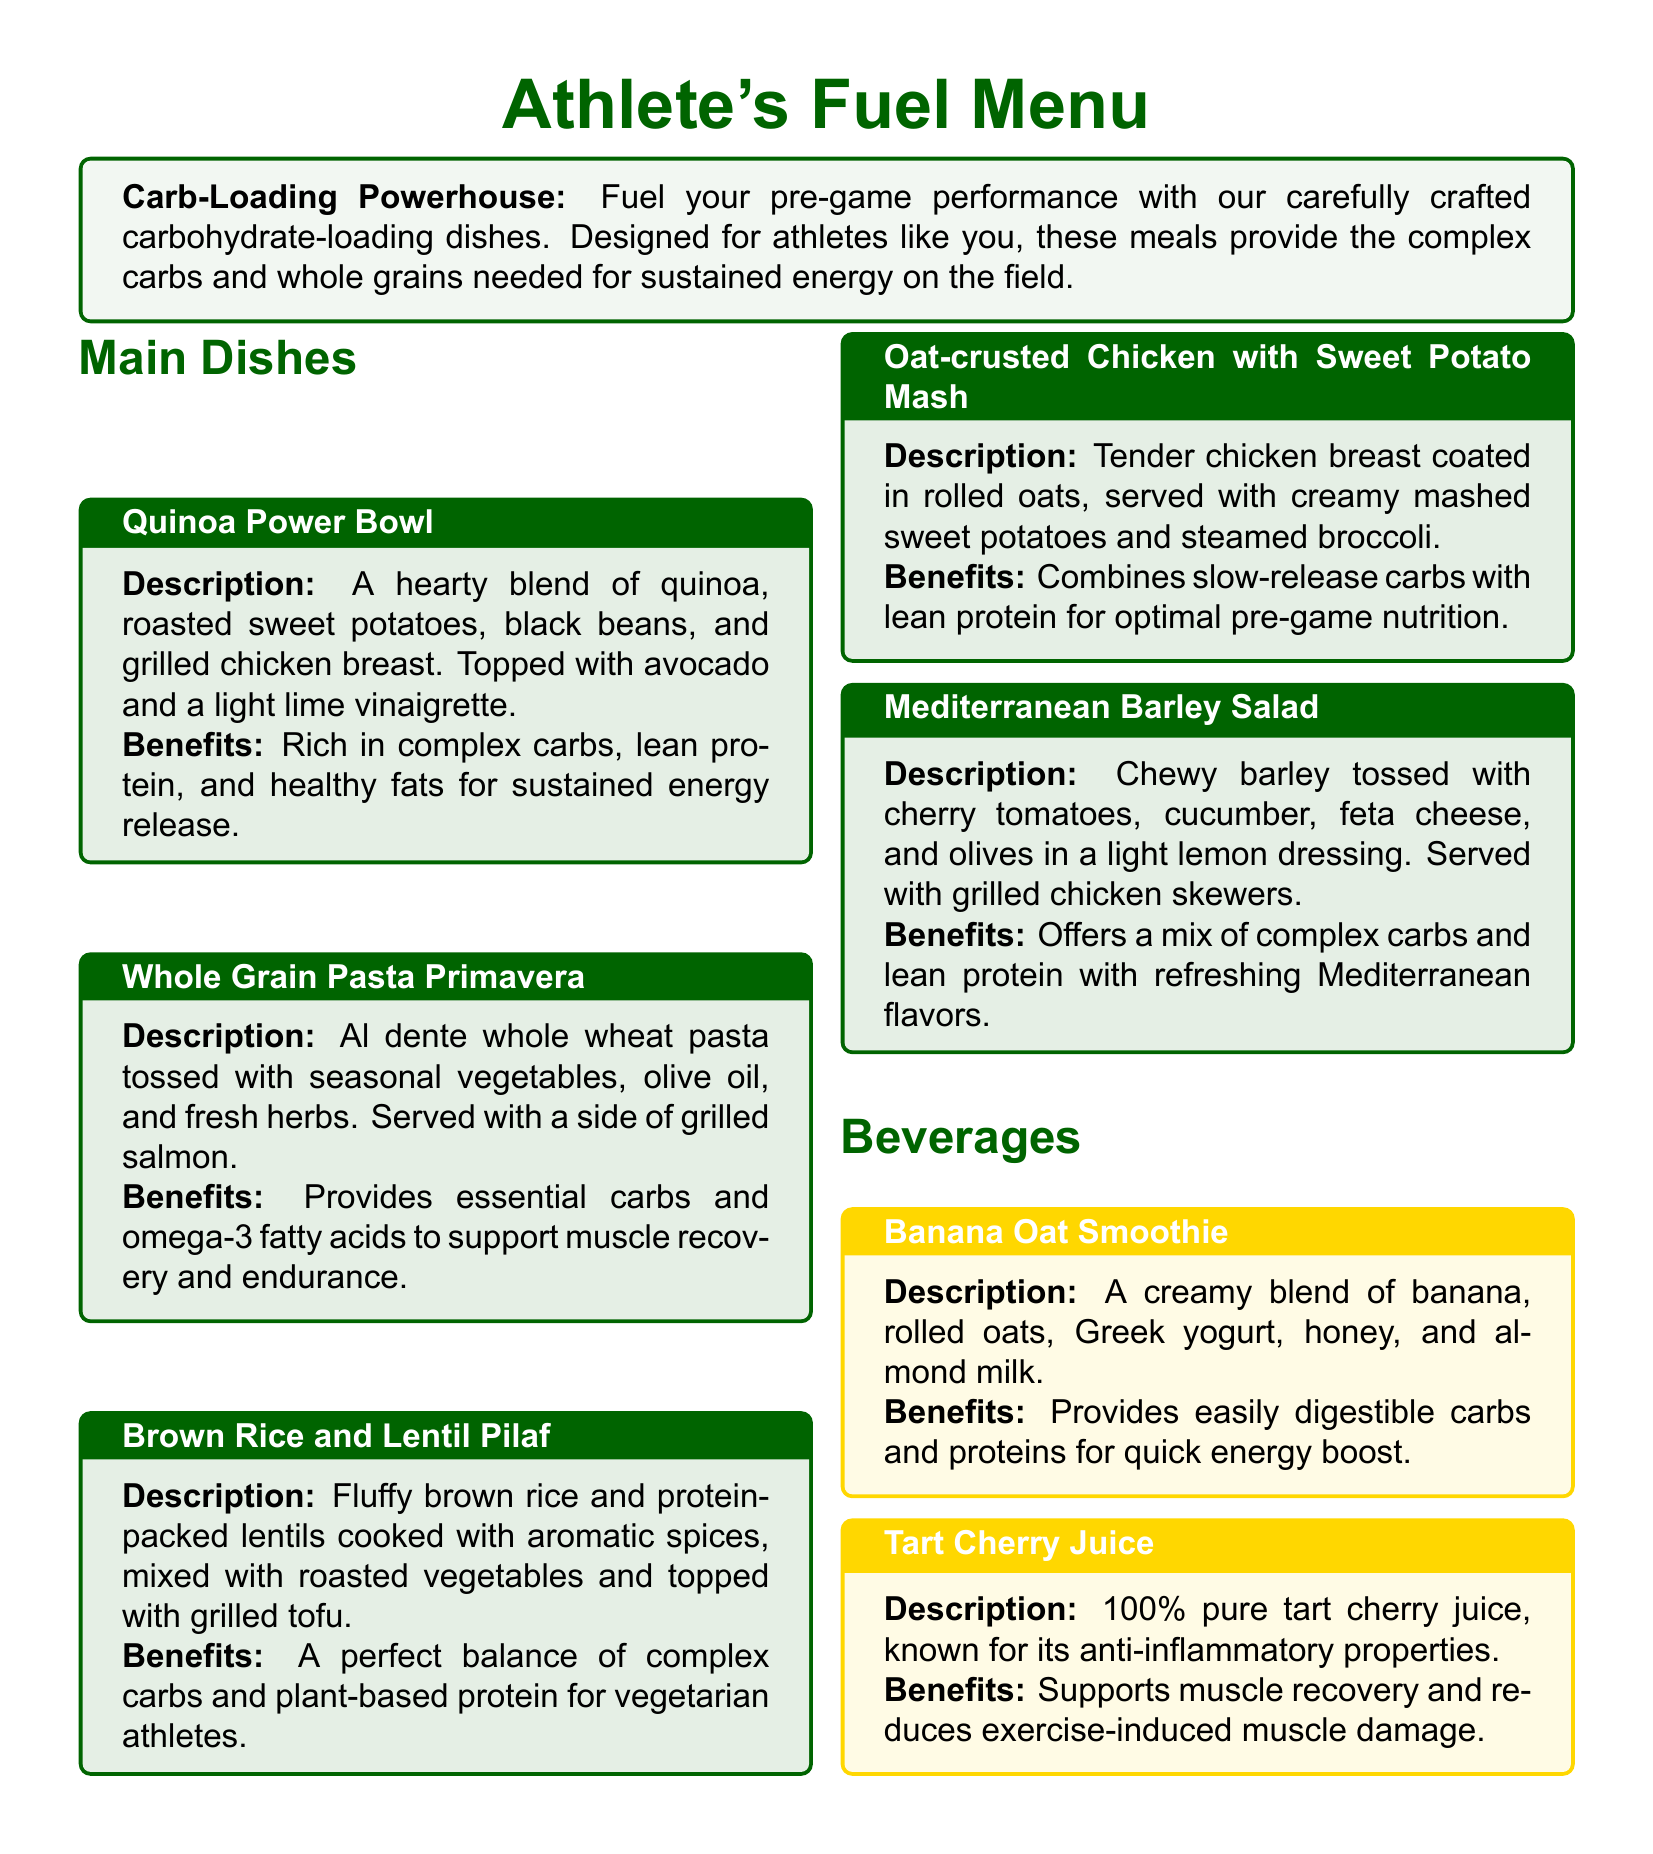what is the title of the menu section? The title of the menu section is stated in a bold font at the beginning and is "Carb-Loading Powerhouse."
Answer: Carb-Loading Powerhouse what is included in the Quinoa Power Bowl? The Quinoa Power Bowl includes quinoa, roasted sweet potatoes, black beans, and grilled chicken breast, topped with avocado and a light lime vinaigrette.
Answer: Quinoa, roasted sweet potatoes, black beans, grilled chicken breast, avocado, lime vinaigrette what type of pasta is used in the Whole Grain Pasta Primavera? The Whole Grain Pasta Primavera uses whole wheat pasta, which is mentioned in the dish description.
Answer: Whole wheat pasta how many main dishes are listed in the menu? The menu lists five main dishes in the "Main Dishes" section.
Answer: Five what is the primary benefit of the Brown Rice and Lentil Pilaf? The primary benefit of the Brown Rice and Lentil Pilaf is its perfect balance of complex carbs and plant-based protein for vegetarian athletes.
Answer: Complex carbs and plant-based protein what is the main ingredient in the Banana Oat Smoothie? The main ingredient in the Banana Oat Smoothie is banana, as it is listed first in the description.
Answer: Banana how does Tart Cherry Juice support muscle recovery? Tart Cherry Juice supports muscle recovery with its known anti-inflammatory properties, as mentioned in its benefits.
Answer: Anti-inflammatory properties which dish combines slow-release carbs with lean protein? The dish that combines slow-release carbs with lean protein is the Oat-crusted Chicken with Sweet Potato Mash.
Answer: Oat-crusted Chicken with Sweet Potato Mash 